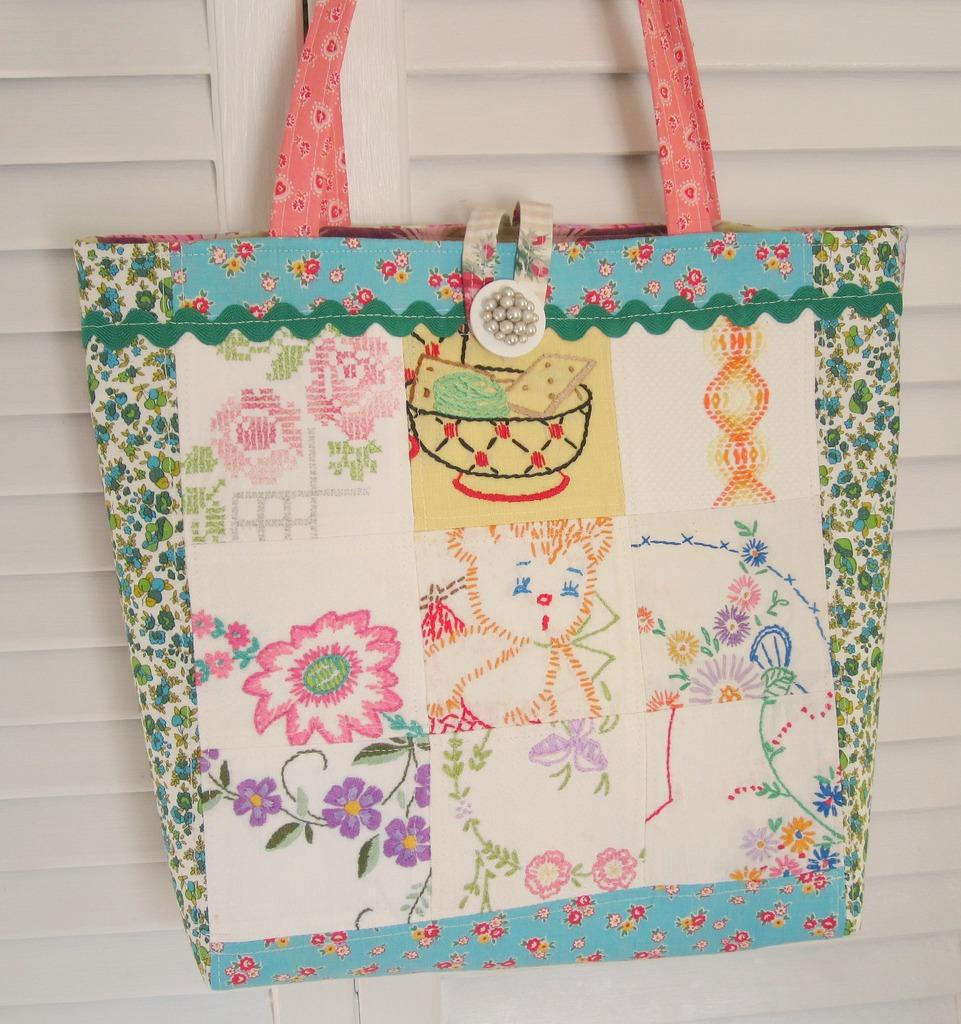What object is the main focus of the image? There is a handbag in the image. Where is the handbag located in the image? The handbag is in the center of the image. What type of beetle can be seen crawling on the ground in the image? There is no beetle or ground present in the image; it only features a handbag in the center. 